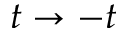Convert formula to latex. <formula><loc_0><loc_0><loc_500><loc_500>t \rightarrow - t</formula> 